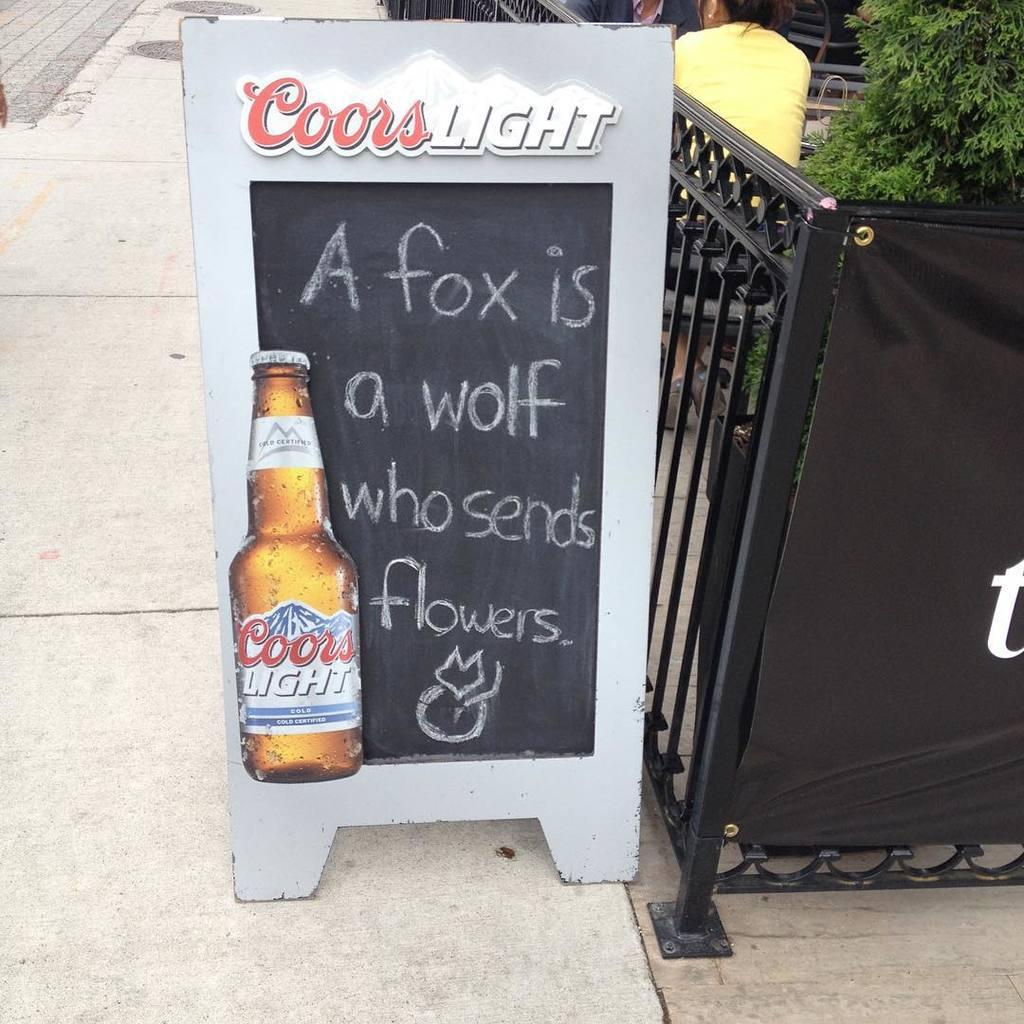What is placed on the footpath in the image? There is a board on the footpath in the image. What can be seen on the right side of the image? There is a gate and a person on the right side of the image. What type of vegetation is on the right side of the image? There is a tree on the right side of the image. How many pizzas are being delivered to the person in the image? There is no mention of pizzas or delivery in the image. What type of work is the person on the right side of the image doing? The image does not provide information about the person's work or occupation. 